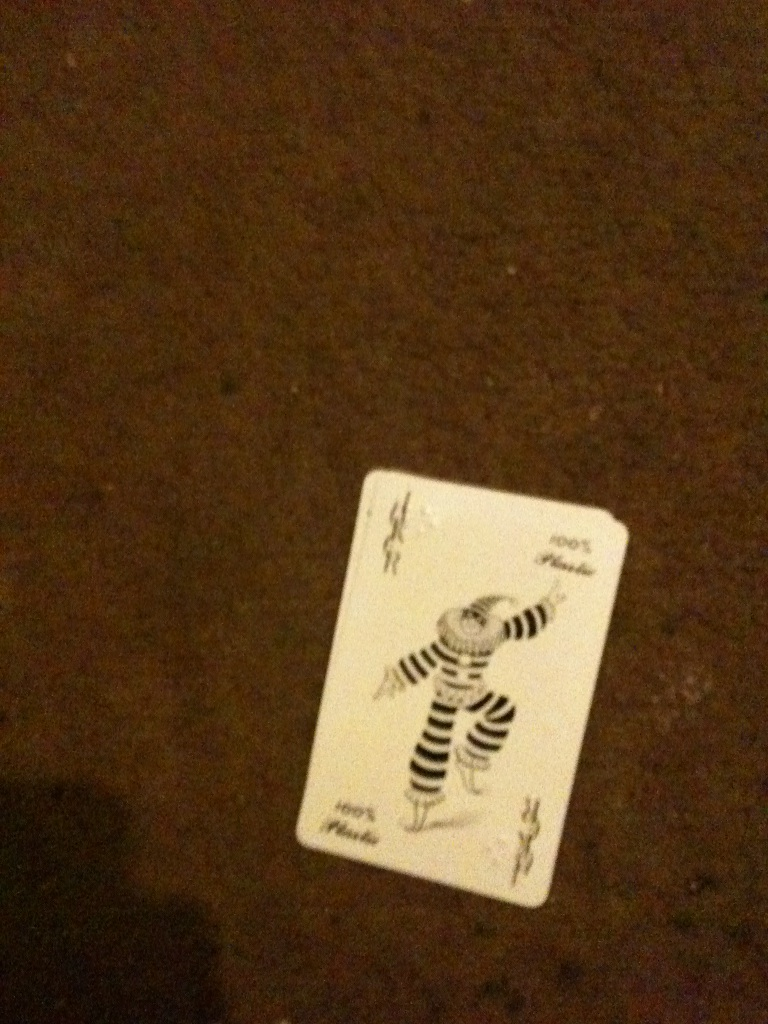What could be the historical origin of the Joker card in traditional playing decks? The Joker card, an addition to the traditional deck of cards, originally appeared in the United States during the late 19th century. It is believed to have been created during the American development of the game of Euchre, where it was first used as the highest trump card. The name 'Joker' and its design, often depicting a court jester or a fool, draw from the historical role of jesters in royal courts – individuals who were given the freedom to mock and entertain. Over time, the Joker card transcended beyond its roots in Euchre and became integrated into many other card games with varying roles, symbolizing versatility and a wild, unpredictable element. 